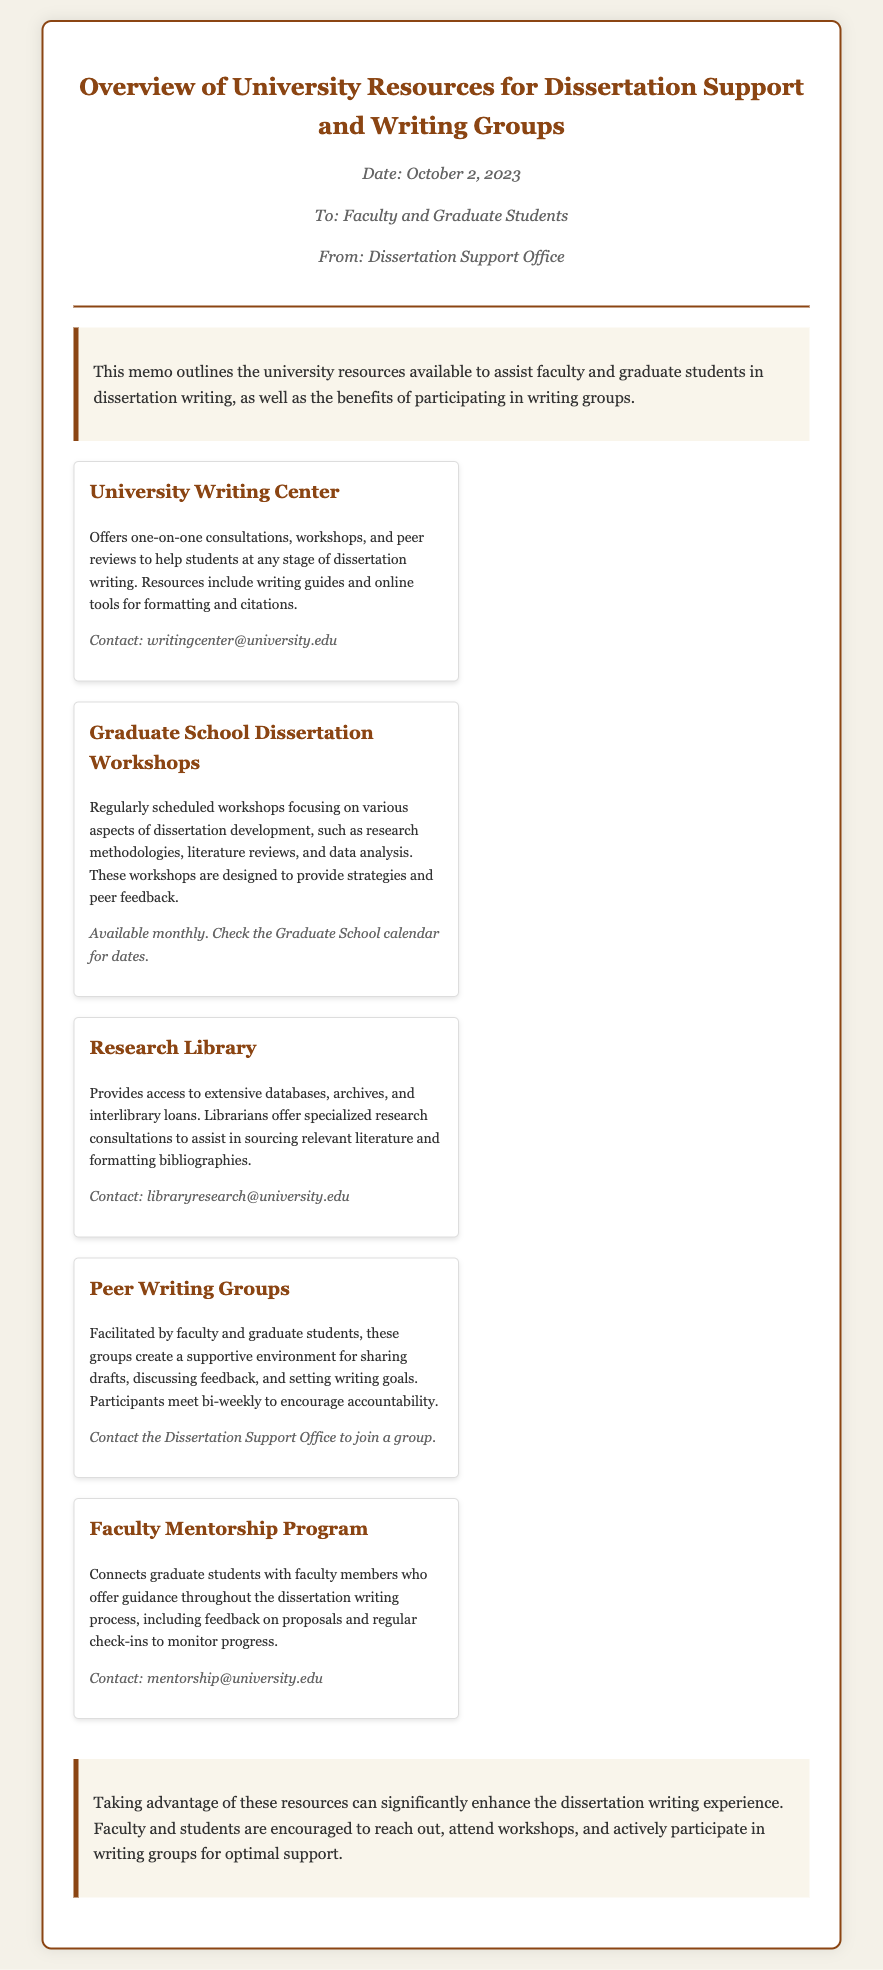What is the date of the memo? The date in the memo is specifically stated at the top, which is October 2, 2023.
Answer: October 2, 2023 Who is the memo addressed to? The recipients of the memo are clearly mentioned in the "To" section.
Answer: Faculty and Graduate Students What is one service provided by the University Writing Center? The memo describes one service offered as one-on-one consultations for students at any stage of dissertation writing.
Answer: One-on-one consultations How often are the Graduate School Dissertation Workshops scheduled? The memo indicates that the workshops are available monthly, thus inferring their schedule frequency.
Answer: Monthly What type of groups are facilitated bi-weekly? The document mentions these groups are for sharing drafts and discussing feedback while encouraging accountability among participants.
Answer: Peer Writing Groups What program connects graduate students with faculty members? The name of the program specifically connecting students with faculty is provided in the memo, which is intended for mentoring.
Answer: Faculty Mentorship Program What is the contact email for the Research Library? The memo lists specific contact information for the Research Library, which includes their email address.
Answer: libraryresearch@university.edu What is the main emphasis of the conclusion in the memo? The conclusion discusses the importance of taking advantage of available resources for enhancing the dissertation writing experience.
Answer: Enhance the dissertation writing experience 